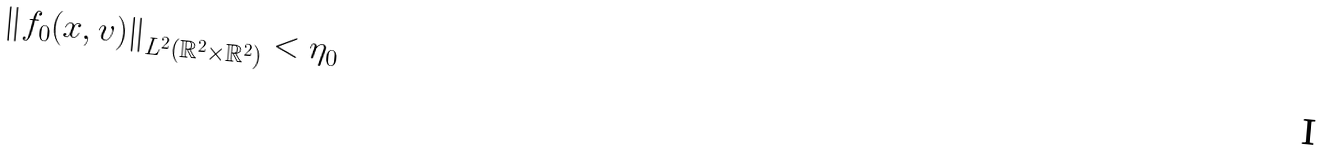<formula> <loc_0><loc_0><loc_500><loc_500>\left \| f _ { 0 } ( x , v ) \right \| _ { L ^ { 2 } \left ( \mathbb { R } ^ { 2 } \times \mathbb { R } ^ { 2 } \right ) } < \eta _ { 0 }</formula> 